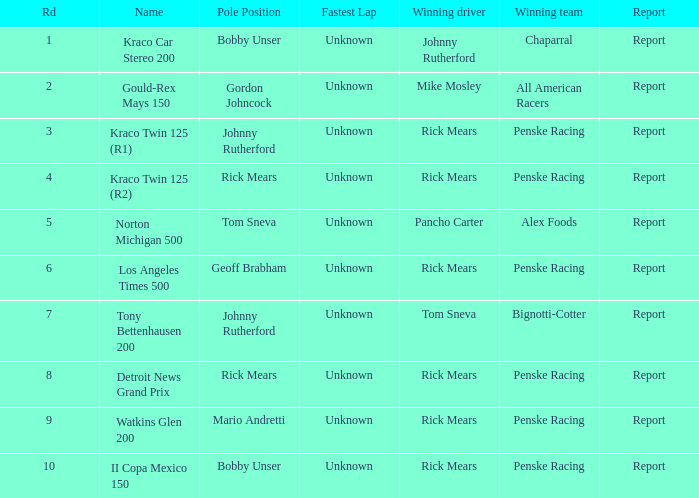Who are the champions of the race, los angeles times 500? Penske Racing. 